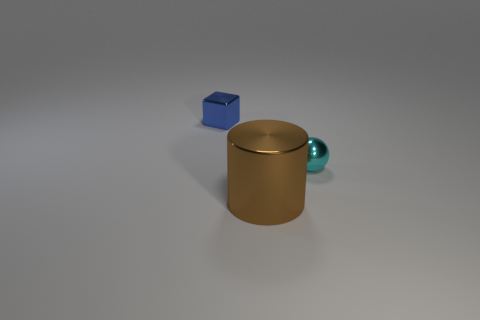Does the thing to the left of the big brown object have the same color as the large metal object?
Your answer should be very brief. No. How many things are either tiny metal objects that are right of the big cylinder or large brown metal things?
Your answer should be very brief. 2. Are there any shiny cylinders in front of the shiny block?
Your answer should be compact. Yes. Are there any brown metallic objects that are in front of the small object that is in front of the tiny metal object that is to the left of the small metal ball?
Make the answer very short. Yes. How many spheres are tiny blue objects or small shiny objects?
Offer a very short reply. 1. There is a small object that is on the left side of the small shiny sphere; what is it made of?
Your response must be concise. Metal. How many things are either large green cylinders or brown metal cylinders?
Your answer should be compact. 1. Is the material of the tiny object on the left side of the small ball the same as the thing on the right side of the large object?
Keep it short and to the point. Yes. What shape is the shiny object that is both behind the large brown cylinder and to the left of the cyan metallic thing?
Make the answer very short. Cube. What material is the thing that is in front of the tiny blue metal block and on the left side of the cyan metal ball?
Your answer should be very brief. Metal. 